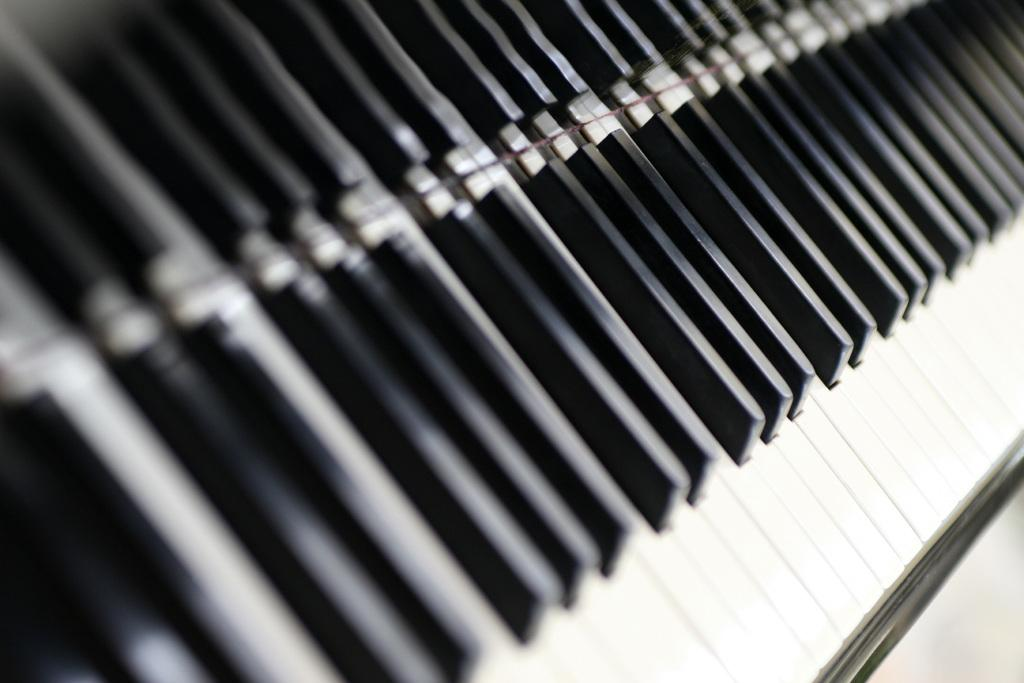What type of musical instrument is visible in the image? There is a musical instrument with white and black keys in the image. How many knives can be seen floating in the sea in the image? There is no sea or knife present in the image; it features a musical instrument with white and black keys. 